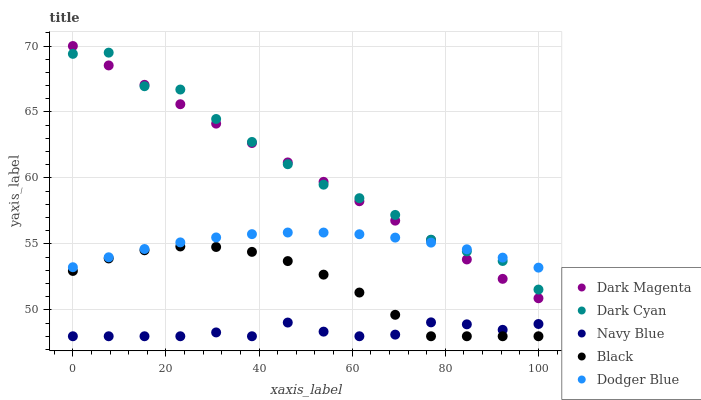Does Navy Blue have the minimum area under the curve?
Answer yes or no. Yes. Does Dark Cyan have the maximum area under the curve?
Answer yes or no. Yes. Does Black have the minimum area under the curve?
Answer yes or no. No. Does Black have the maximum area under the curve?
Answer yes or no. No. Is Dark Magenta the smoothest?
Answer yes or no. Yes. Is Dark Cyan the roughest?
Answer yes or no. Yes. Is Navy Blue the smoothest?
Answer yes or no. No. Is Navy Blue the roughest?
Answer yes or no. No. Does Navy Blue have the lowest value?
Answer yes or no. Yes. Does Dark Magenta have the lowest value?
Answer yes or no. No. Does Dark Magenta have the highest value?
Answer yes or no. Yes. Does Black have the highest value?
Answer yes or no. No. Is Black less than Dodger Blue?
Answer yes or no. Yes. Is Dark Cyan greater than Navy Blue?
Answer yes or no. Yes. Does Dark Cyan intersect Dodger Blue?
Answer yes or no. Yes. Is Dark Cyan less than Dodger Blue?
Answer yes or no. No. Is Dark Cyan greater than Dodger Blue?
Answer yes or no. No. Does Black intersect Dodger Blue?
Answer yes or no. No. 